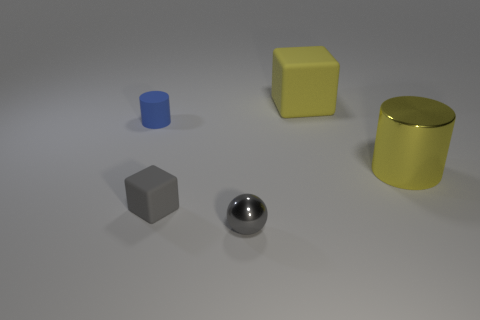There is a tiny ball that is made of the same material as the big yellow cylinder; what color is it?
Give a very brief answer. Gray. Are there any blue things of the same size as the gray rubber object?
Offer a terse response. Yes. There is another object that is the same shape as the blue matte thing; what is it made of?
Make the answer very short. Metal. What shape is the other object that is the same size as the yellow rubber thing?
Keep it short and to the point. Cylinder. Is there another small object that has the same shape as the gray shiny thing?
Your answer should be compact. No. What is the shape of the large yellow object that is behind the big thing that is in front of the blue cylinder?
Offer a terse response. Cube. What shape is the yellow rubber thing?
Provide a short and direct response. Cube. There is a large object behind the cylinder right of the small gray thing that is to the left of the tiny gray shiny object; what is its material?
Provide a short and direct response. Rubber. How many other objects are there of the same material as the ball?
Offer a very short reply. 1. What number of matte blocks are behind the rubber cube that is behind the tiny cube?
Offer a terse response. 0. 